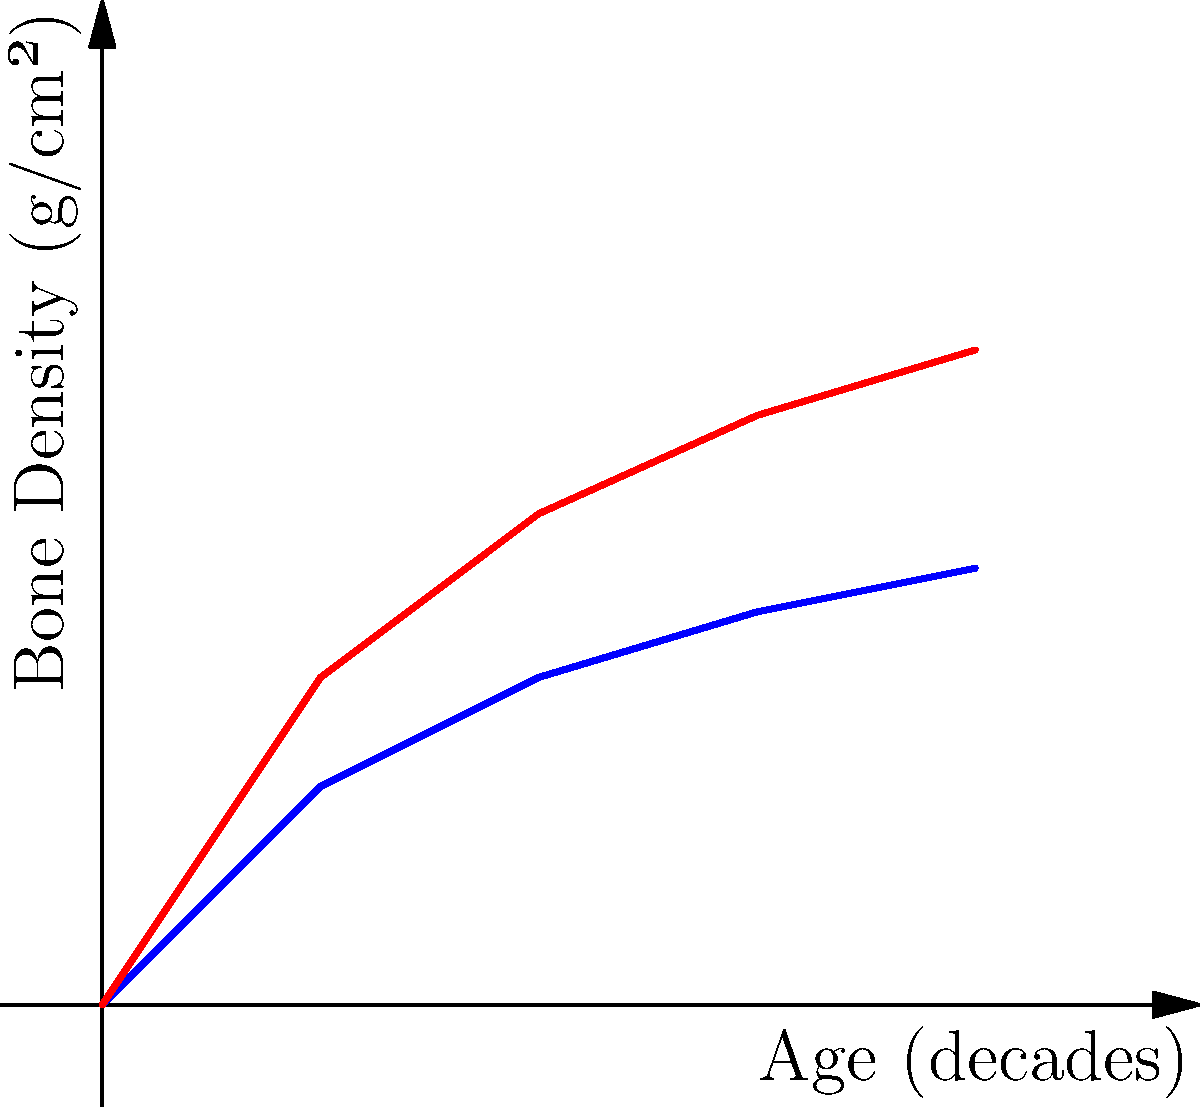A visual representation of bone density changes over four decades is scaled vertically by a factor of 1.5. If the original graph shows a bone density of 2 g/cm² at the end of the fourth decade, what is the corresponding value on the scaled graph? To solve this problem, we need to understand how scaling affects the graph:

1. The original graph shows a bone density of 2 g/cm² at the end of the fourth decade.
2. The graph is scaled vertically by a factor of 1.5.
3. Vertical scaling affects the y-values (bone density) but not the x-values (age).
4. To find the new y-value, we multiply the original y-value by the scaling factor.

Calculation:
$$ \text{New bone density} = \text{Original bone density} \times \text{Scaling factor} $$
$$ \text{New bone density} = 2 \text{ g/cm²} \times 1.5 $$
$$ \text{New bone density} = 3 \text{ g/cm²} $$

Therefore, on the scaled graph, the bone density at the end of the fourth decade is 3 g/cm².
Answer: 3 g/cm² 